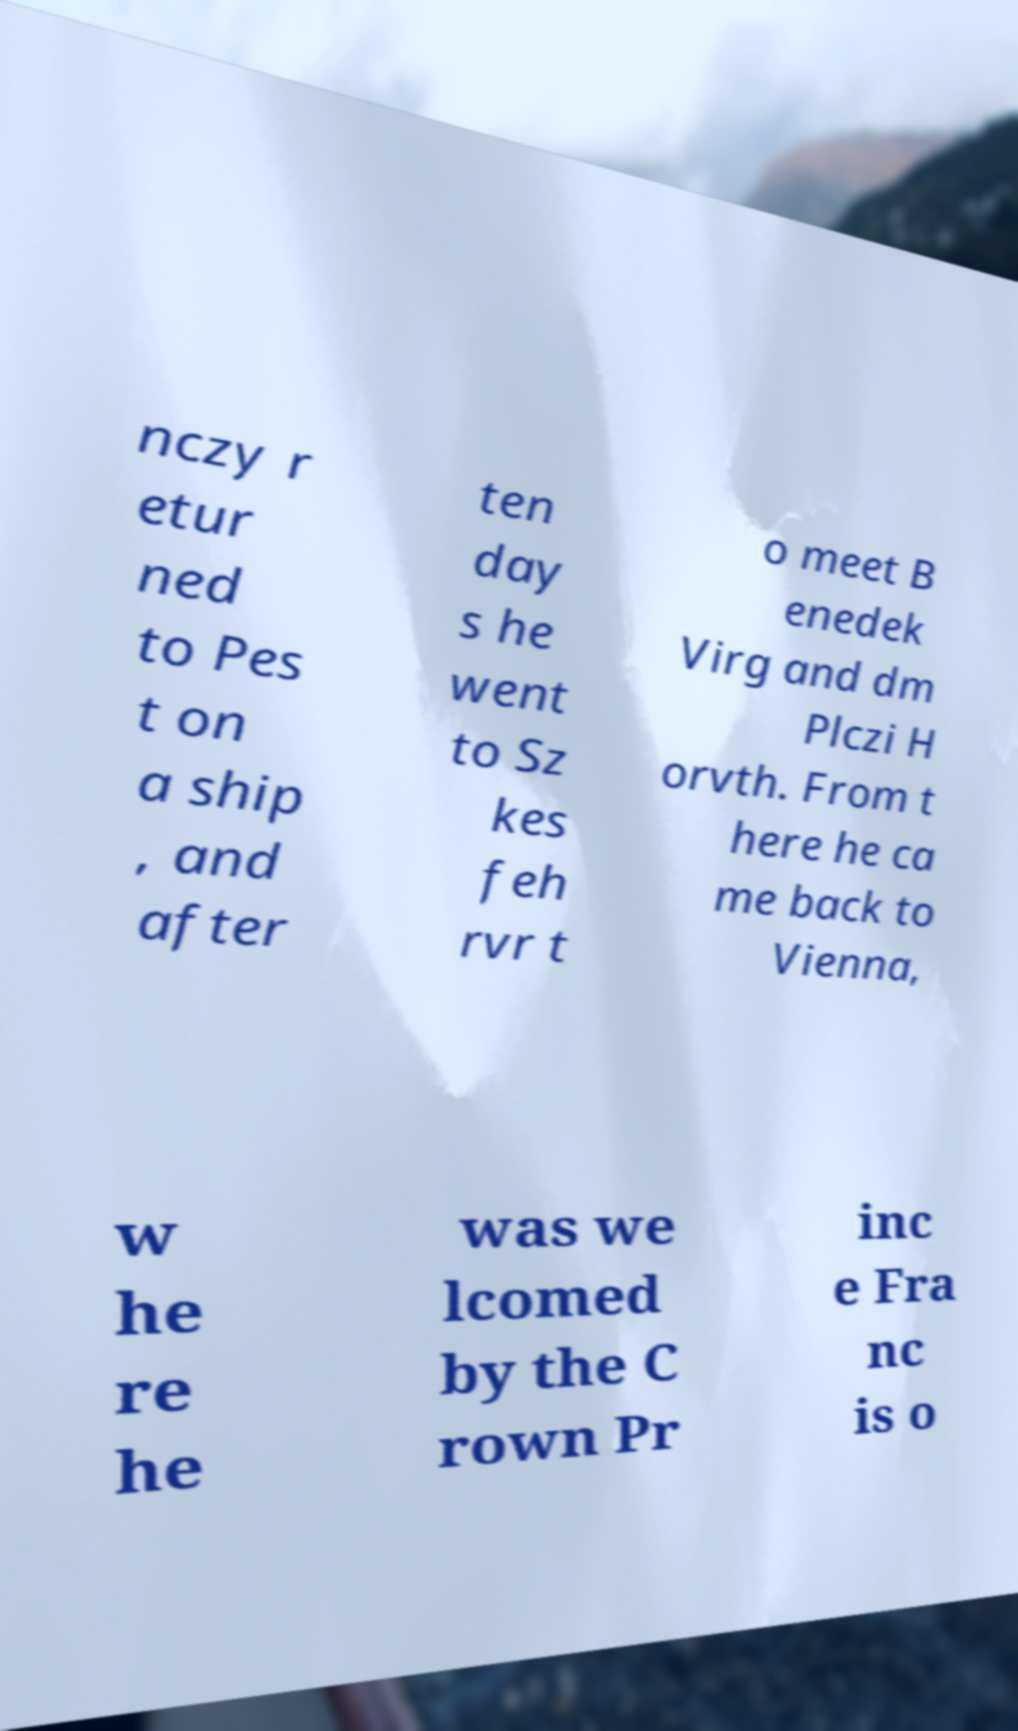Please read and relay the text visible in this image. What does it say? nczy r etur ned to Pes t on a ship , and after ten day s he went to Sz kes feh rvr t o meet B enedek Virg and dm Plczi H orvth. From t here he ca me back to Vienna, w he re he was we lcomed by the C rown Pr inc e Fra nc is o 